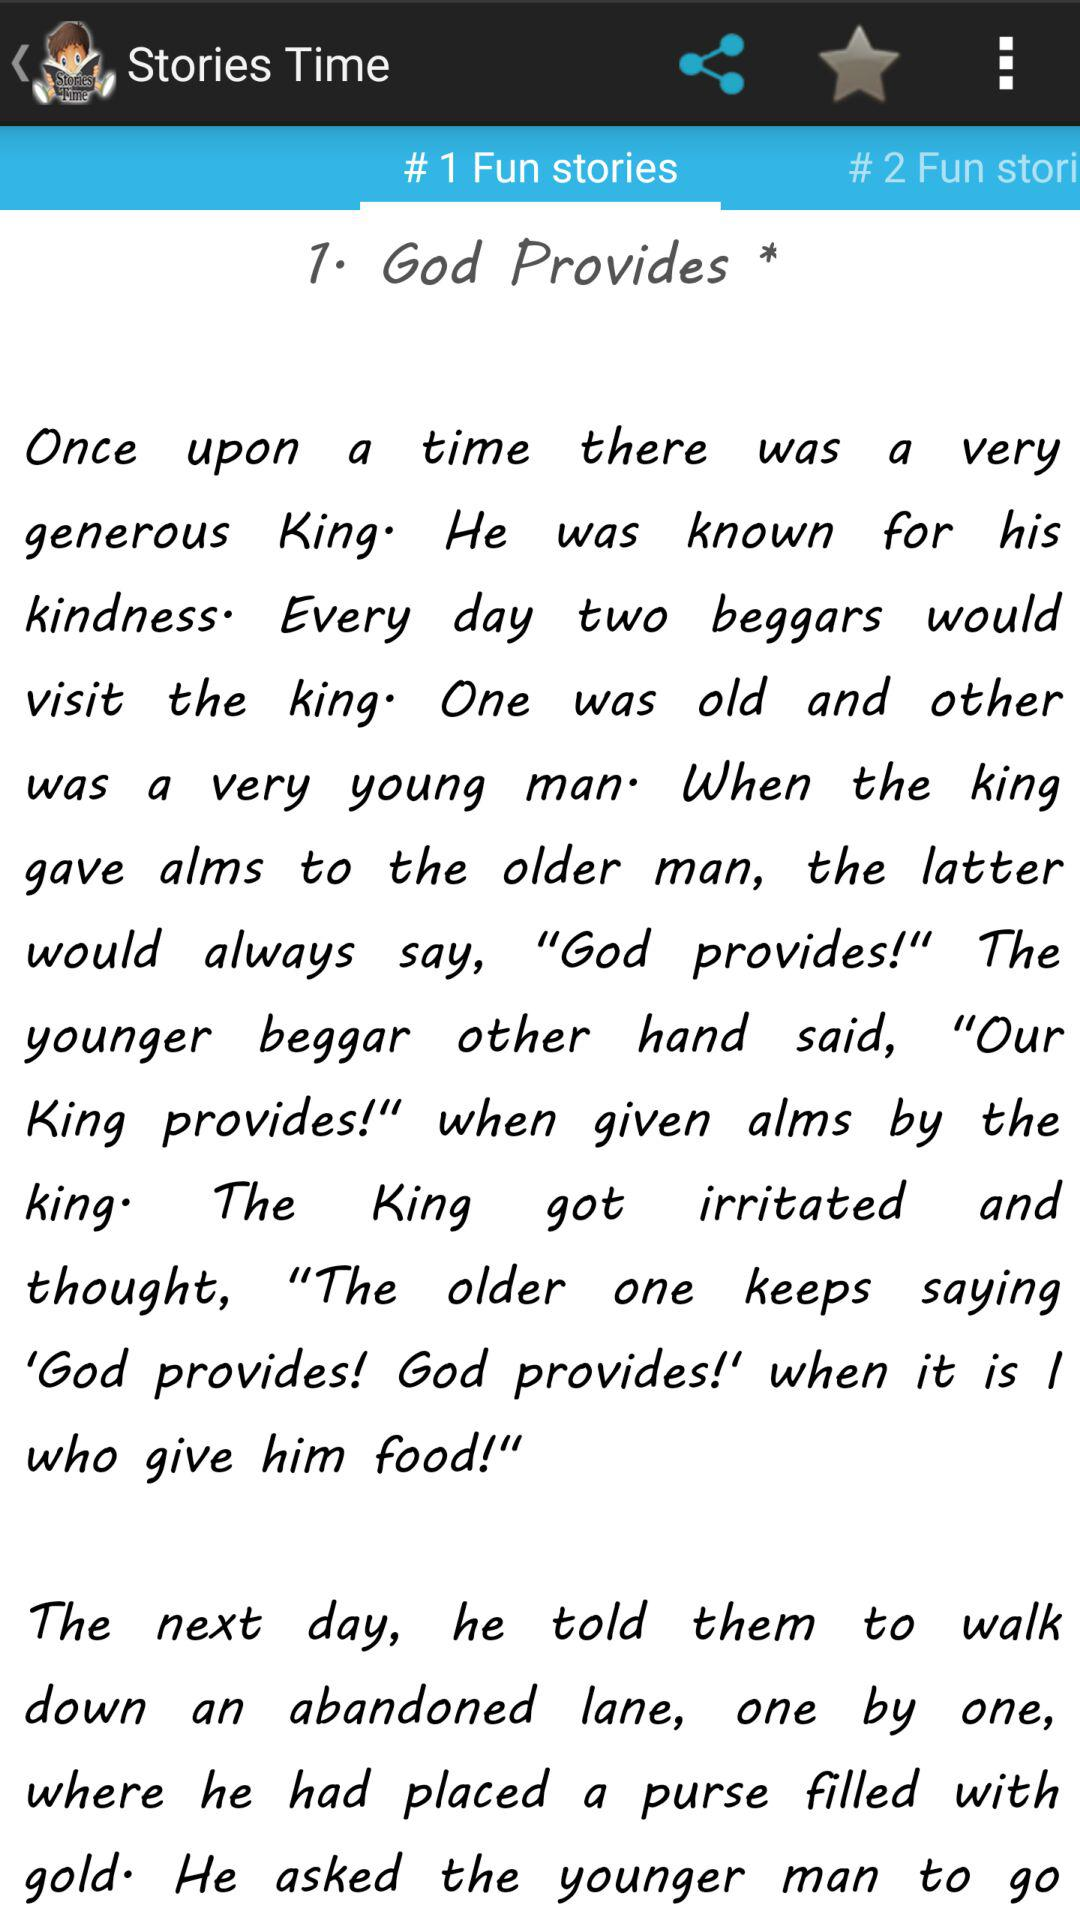At which tab of the application are we? You are at the "# 1 Fun stories" tab. 